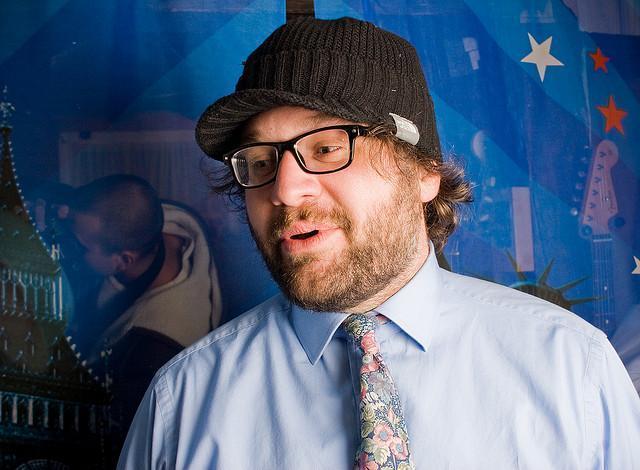How many men are there?
Give a very brief answer. 1. How many people are there?
Give a very brief answer. 2. How many sandwiches with tomato are there?
Give a very brief answer. 0. 